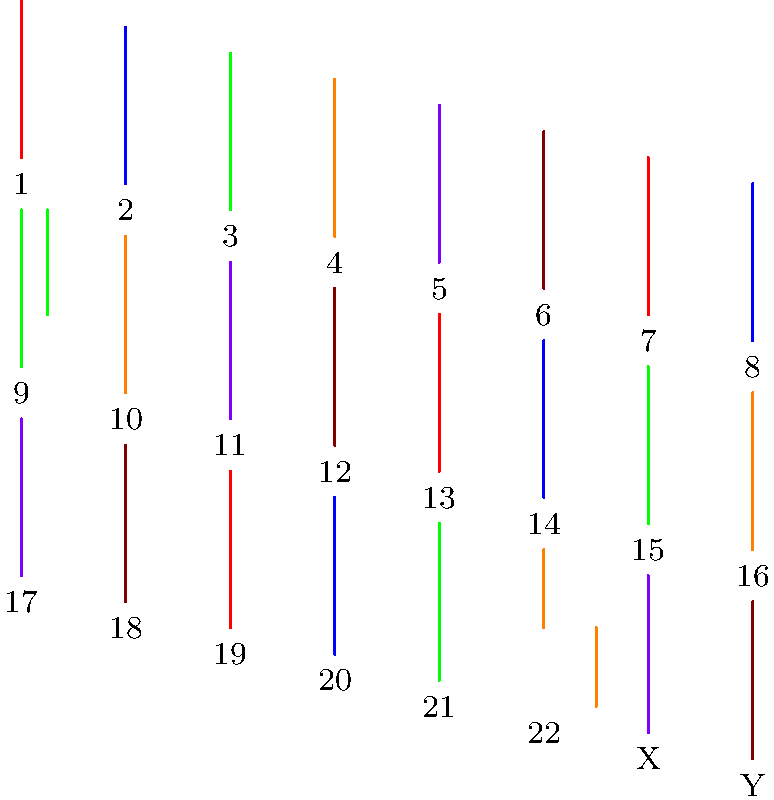Analyze the karyotype image provided. Which chromosomal abnormality associated with childhood leukemia is represented, and what is its specific name? To identify the chromosomal abnormality in this karyotype:

1. Examine all chromosomes for any structural changes.
2. Notice that chromosome 9 appears to have a piece missing.
3. Observe that chromosome 22 has an extra piece attached.
4. This pattern suggests a translocation between chromosomes 9 and 22.
5. The specific translocation involving these chromosomes is known as the Philadelphia chromosome.
6. It's represented as t(9;22)(q34;q11).
7. This translocation results in the fusion of the BCR gene on chromosome 22 with the ABL1 gene on chromosome 9.
8. The Philadelphia chromosome is commonly associated with chronic myeloid leukemia (CML) but can also occur in acute lymphoblastic leukemia (ALL), particularly in children.
9. In pediatric cases, it's more frequently seen in ALL than in CML.
10. The presence of the Philadelphia chromosome in childhood leukemia often indicates a poorer prognosis and may require more intensive treatment approaches.
Answer: Philadelphia chromosome t(9;22)(q34;q11) 